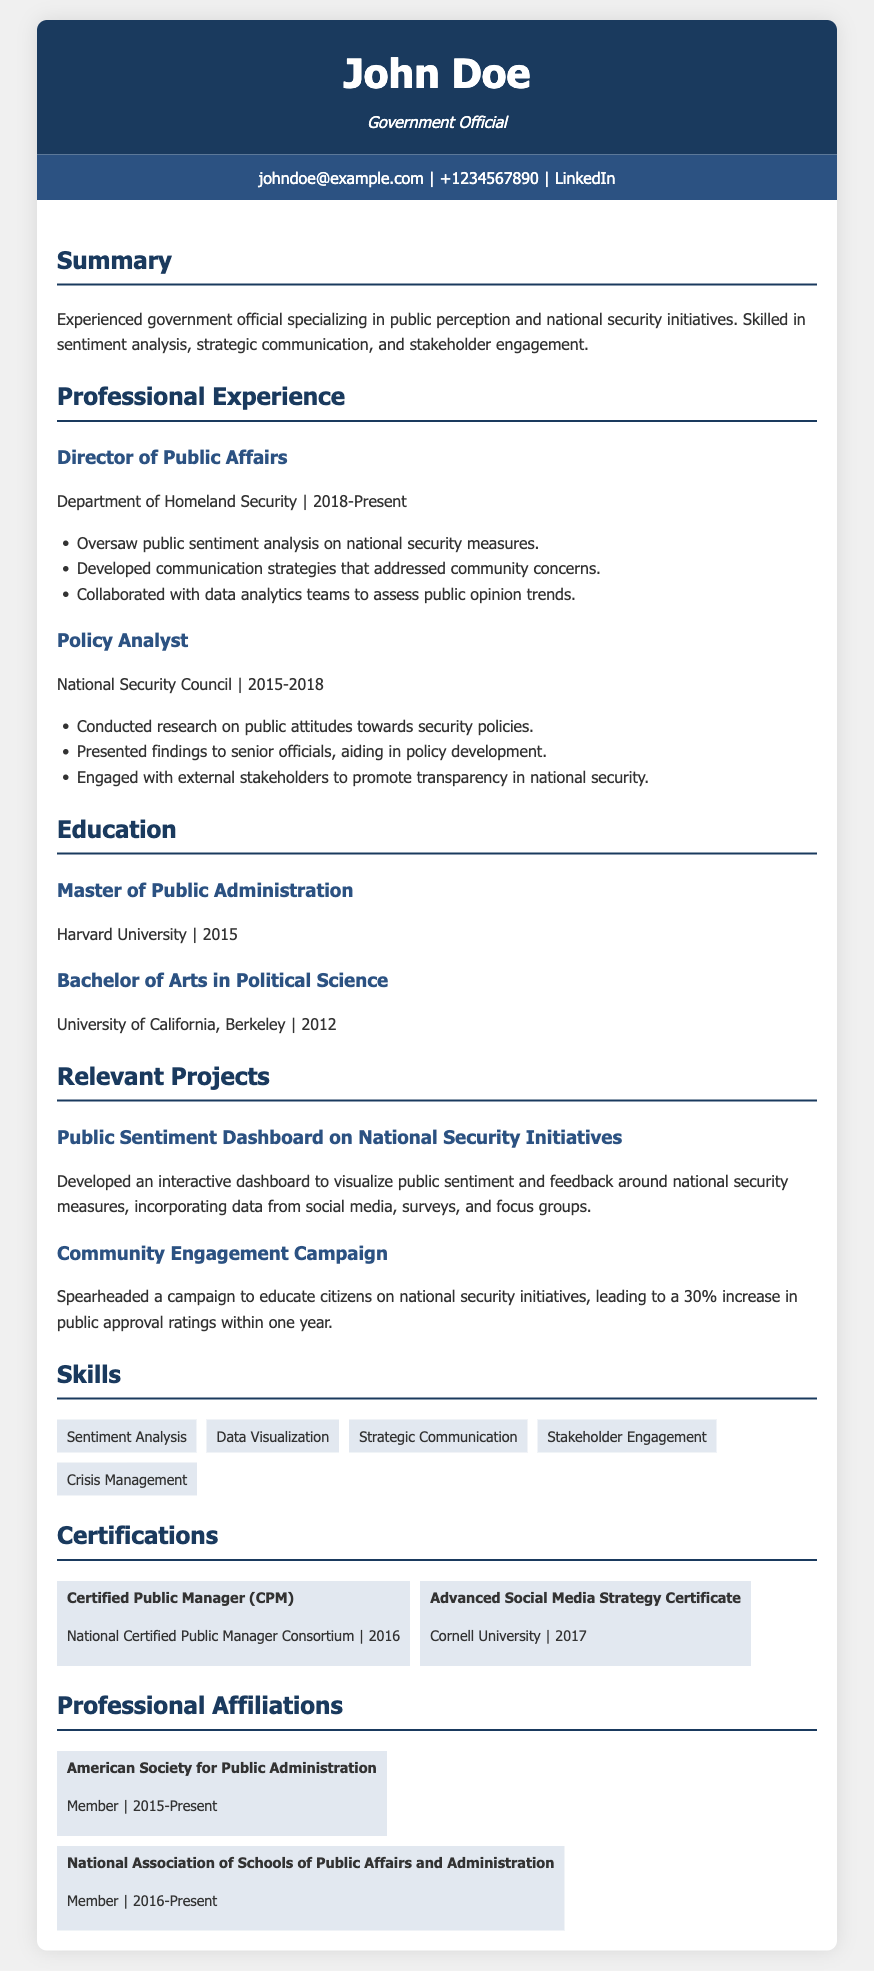What is the name of the individual? The name of the individual is listed at the top of the document under the header section.
Answer: John Doe What position does John Doe currently hold? The document states the current position held by John Doe under the Professional Experience section.
Answer: Director of Public Affairs Which department did John Doe work for from 2015 to 2018? The document provides the name of the department in the Professional Experience section for the specified timeframe.
Answer: National Security Council What educational qualification does John Doe have from Harvard University? The document outlines John Doe's educational achievements, particularly from Harvard University, in the Education section.
Answer: Master of Public Administration How much did public approval ratings increase after the community engagement campaign? The document specifies the percentage increase in public approval ratings as a result of a particular project.
Answer: 30% How many skills are listed under the Skills section? The Skills section of the document contains multiple skill items that can be counted.
Answer: 5 When did John Doe receive the Certified Public Manager certification? The document includes the year John Doe obtained a specific certification in the Certifications section.
Answer: 2016 What is the title of the project focused on public sentiment analysis? The project titles are displayed in the Relevant Projects section, and this particular project is explicitly named there.
Answer: Public Sentiment Dashboard on National Security Initiatives Which organization is John Doe affiliated with since 2015? The document mentions professional affiliations, including the year John Doe joined a specific organization.
Answer: American Society for Public Administration 